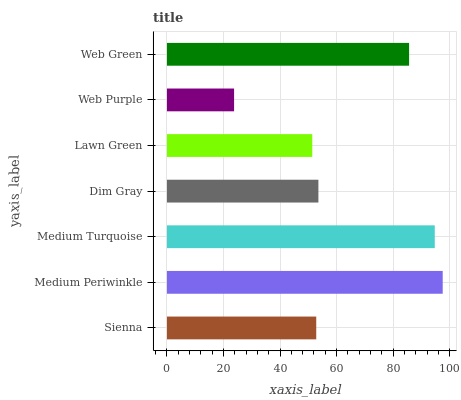Is Web Purple the minimum?
Answer yes or no. Yes. Is Medium Periwinkle the maximum?
Answer yes or no. Yes. Is Medium Turquoise the minimum?
Answer yes or no. No. Is Medium Turquoise the maximum?
Answer yes or no. No. Is Medium Periwinkle greater than Medium Turquoise?
Answer yes or no. Yes. Is Medium Turquoise less than Medium Periwinkle?
Answer yes or no. Yes. Is Medium Turquoise greater than Medium Periwinkle?
Answer yes or no. No. Is Medium Periwinkle less than Medium Turquoise?
Answer yes or no. No. Is Dim Gray the high median?
Answer yes or no. Yes. Is Dim Gray the low median?
Answer yes or no. Yes. Is Web Green the high median?
Answer yes or no. No. Is Web Green the low median?
Answer yes or no. No. 